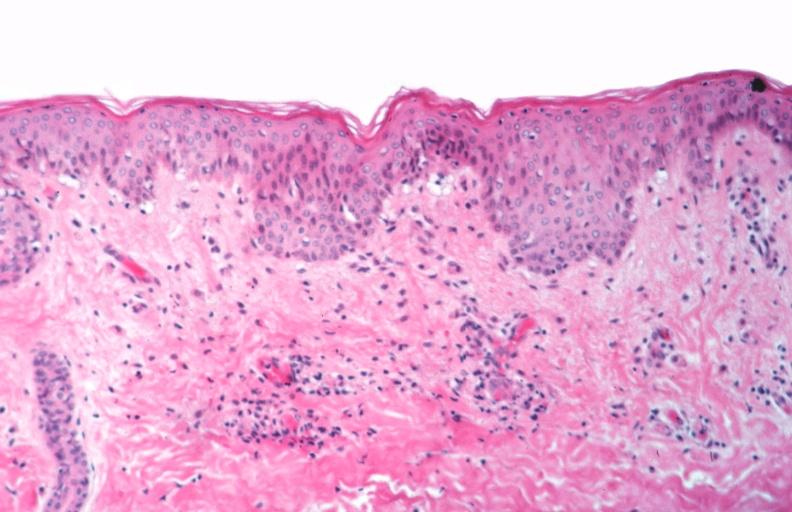what spotted fever, vasculitis?
Answer the question using a single word or phrase. Rocky mountain 